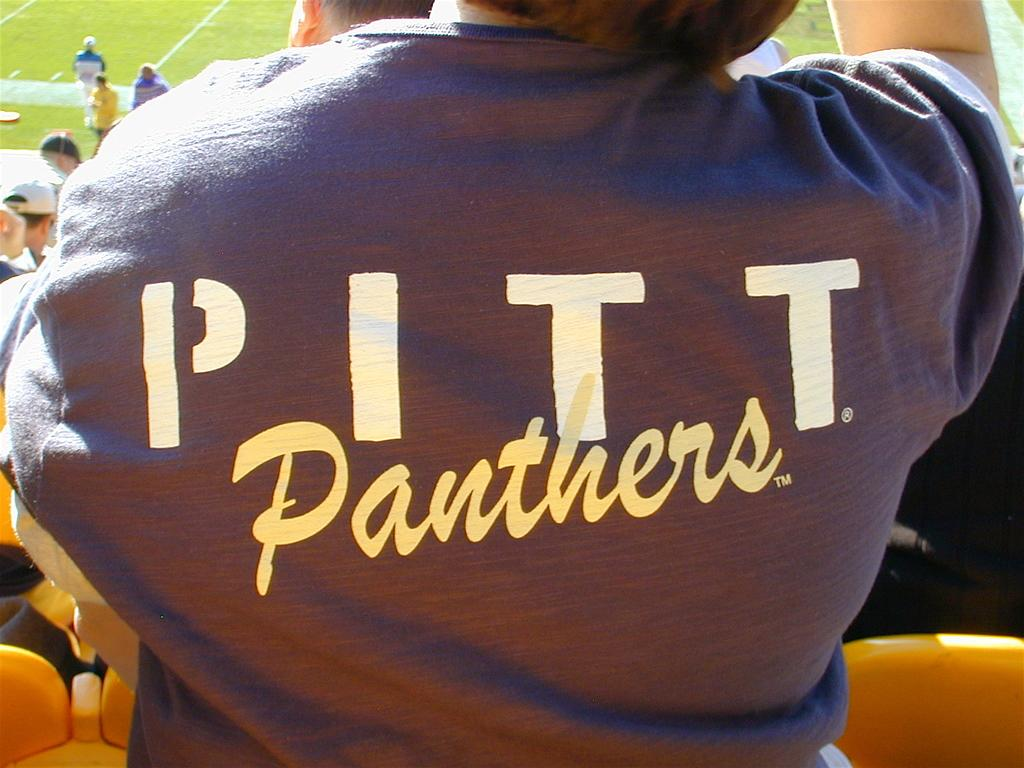<image>
Relay a brief, clear account of the picture shown. An up close shot of a shirt that reads panthers on it. 